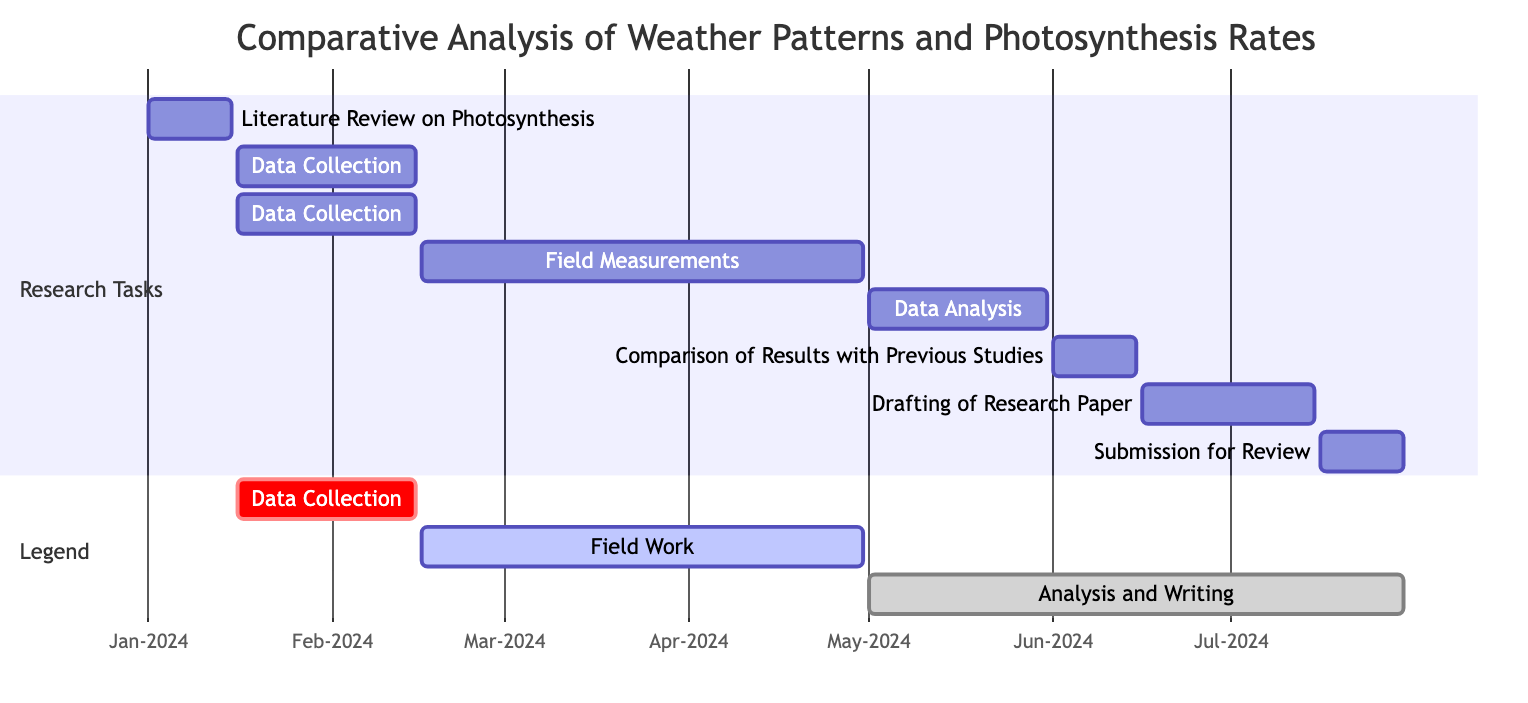What is the duration of the "Literature Review on Photosynthesis" task? The "Literature Review on Photosynthesis" task starts on January 1, 2024, and ends on January 15, 2024. This gives us a duration of 15 days.
Answer: 15 days How many tasks are scheduled in the "Data Collection" section? There are two tasks listed in the "Data Collection" section: "Data Collection: Temperature Records" and "Data Collection: Precipitation Records".
Answer: 2 tasks Which task follows "Field Measurements: Photosynthesis Rates"? The task that follows "Field Measurements: Photosynthesis Rates" is "Data Analysis: Correlation of Weather Patterns", as it starts immediately after the former ends.
Answer: Data Analysis: Correlation of Weather Patterns What is the start date of the "Drafting of Research Paper" task? The "Drafting of Research Paper" task begins on June 16, 2024, as indicated in the diagram.
Answer: June 16, 2024 What is the total time span for the whole project as displayed in the diagram? The first task starts on January 1, 2024, and the last task ends on July 30, 2024. This means the total time span is from January 1 to July 30, which is 211 days.
Answer: 211 days Which task has the longest duration in the diagram? The "Field Measurements: Photosynthesis Rates" task has the longest duration, spanning from February 16, 2024, to April 30, 2024, equating to 74 days.
Answer: Field Measurements: Photosynthesis Rates What is the end date of the "Comparison of Results with Previous Studies" task? The "Comparison of Results with Previous Studies" task ends on June 15, 2024, as noted in the timeline.
Answer: June 15, 2024 How many tasks are scheduled to be completed after May 31, 2024? After May 31, 2024, there are three tasks scheduled to be completed: "Comparison of Results with Previous Studies", "Drafting of Research Paper", and "Submission for Review".
Answer: 3 tasks Which section contains tasks classified as "active"? The section "Field Work" includes tasks categorized as "active", specifically the "Field Measurements: Photosynthesis Rates" task.
Answer: Field Work 